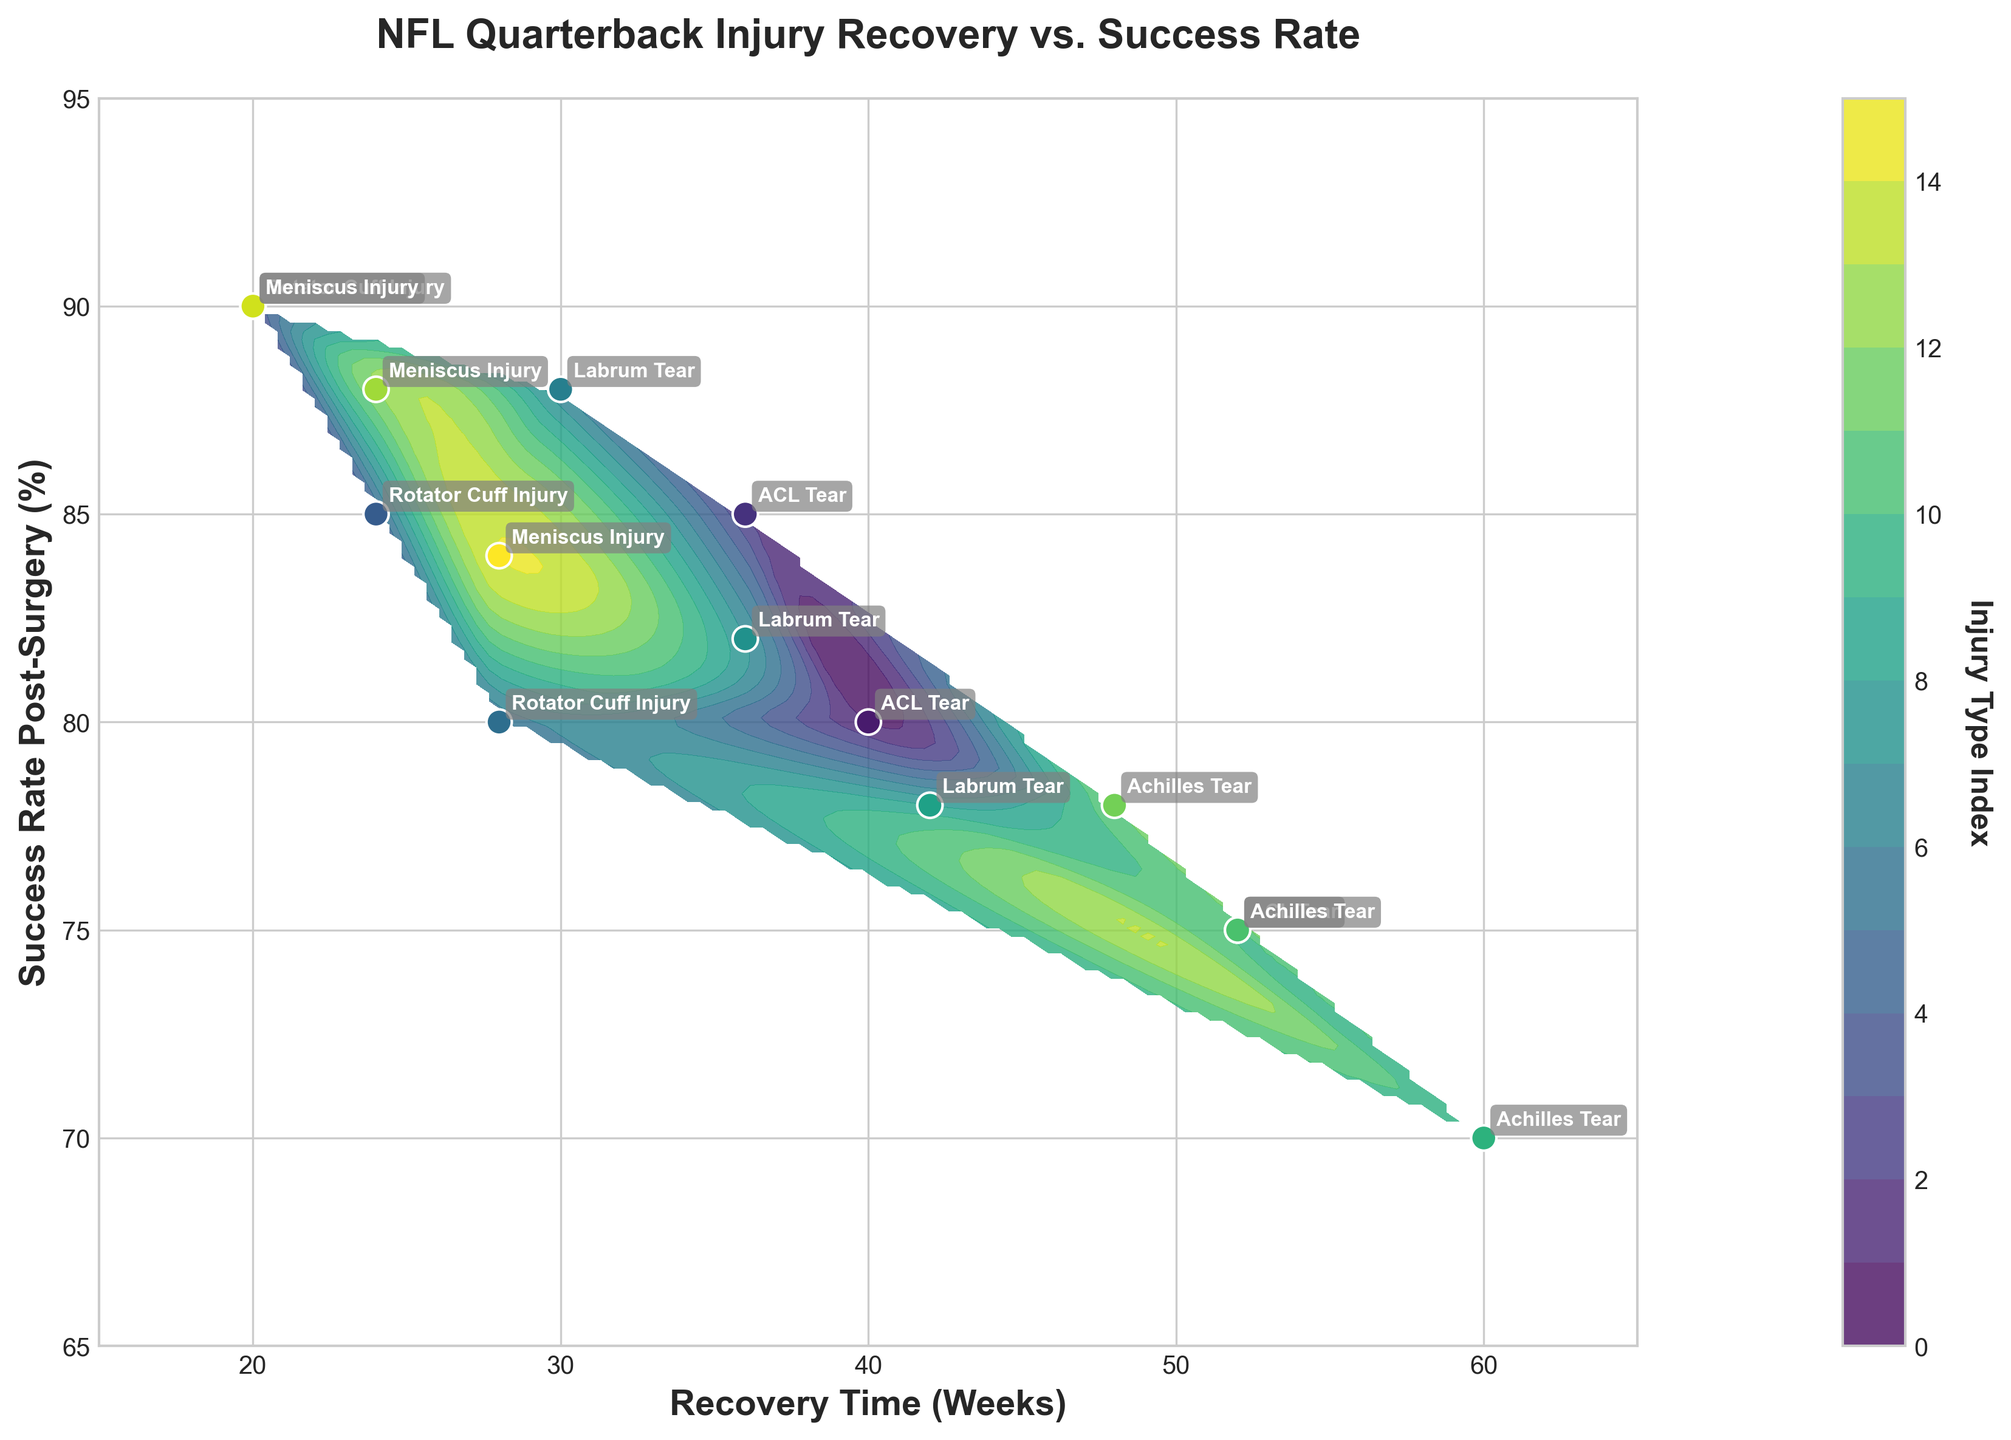What is the title of the plot? The title of the plot is written at the top and helps understand the focus of the figure.
Answer: NFL Quarterback Injury Recovery vs. Success Rate What are the axes labels? The axes labels are written beside the x-axis and y-axis and indicate what each axis represents.
Answer: Recovery Time (Weeks) and Success Rate Post-Surgery (%) How many data points are there in the plot? Each data point in the plot represents a combination of recovery time and success rate for a specific injury type. By counting the points, you can determine the number.
Answer: 15 Which injury type has the highest success rate post-surgery? To find this, look for the data point with the highest position on the y-axis and identify the corresponding injury type annotated beside it.
Answer: Rotator Cuff Injury Which injury type has the longest recovery time? Look for the data point furthest to the right on the x-axis and identify the corresponding injury type annotated beside it.
Answer: Achilles Tear Among the annotated injuries, which one has the lowest success rate post-surgery? To identify this, find the data point with the lowest position on the y-axis and check the annotation nearest to it.
Answer: Achilles Tear What is the general trend of success rates as recovery times increase for ACL Tears? Observe the positions of the data points for ACL tears. Determine if the success rates generally increase, decrease, or have no clear pattern as recovery times increase on the x-axis.
Answer: Success rate decreases Compare the success rates post-surgery of Rotator Cuff Injuries for recovery times 20 and 28 weeks. Locate the data points corresponding to Rotator Cuff Injuries at 20 and 28 weeks on the x-axis and compare their y-axis values.
Answer: 90% (20 weeks) and 80% (28 weeks) What common trend can be observed regarding the success rate with different recovery times for Meniscus Injuries? Look at the three data points for Meniscus Injuries to determine if there is a pattern showing how success rates change with various recovery times.
Answer: Higher for shorter recovery times Which injury type shows the highest variability in recovery times? Compare the range of recovery times for each injury type by observing the spread of data points along the x-axis for each category.
Answer: ACL Tear 